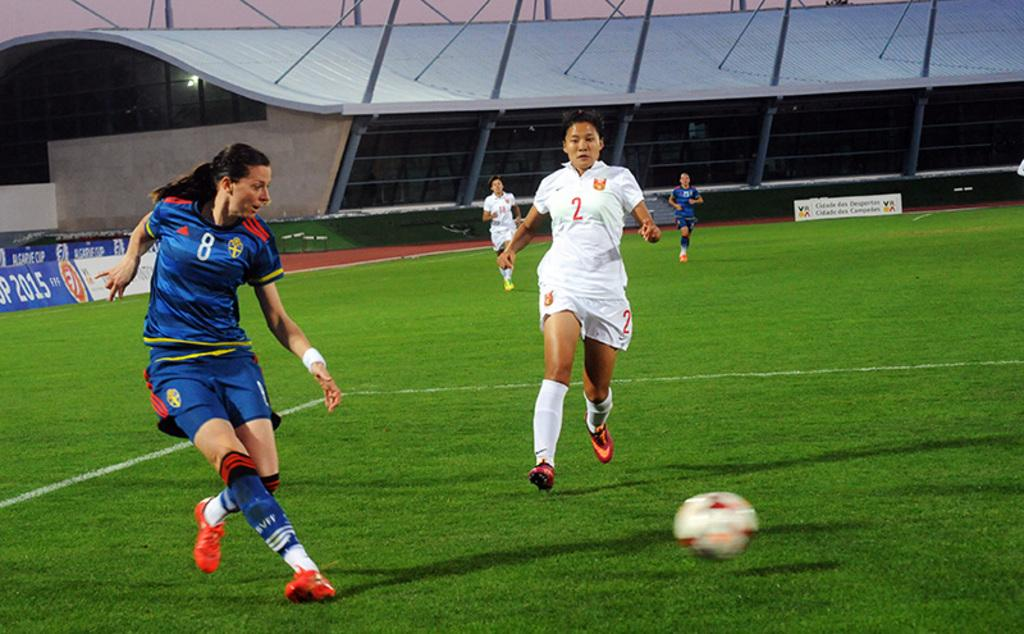What can be seen on the ground in the image? There are people on the ground in the image. What object is visible in the image that people might play with? There is a ball visible in the image. What can be seen in the background of the image? There are advertisement boards and a shed in the background of the image. Can you describe any other objects visible in the background of the image? There are some objects visible in the background of the image. What type of quartz can be seen in the image? There is no quartz present in the image. What rule is being enforced by the people in the image? There is no indication of any rule being enforced in the image. 